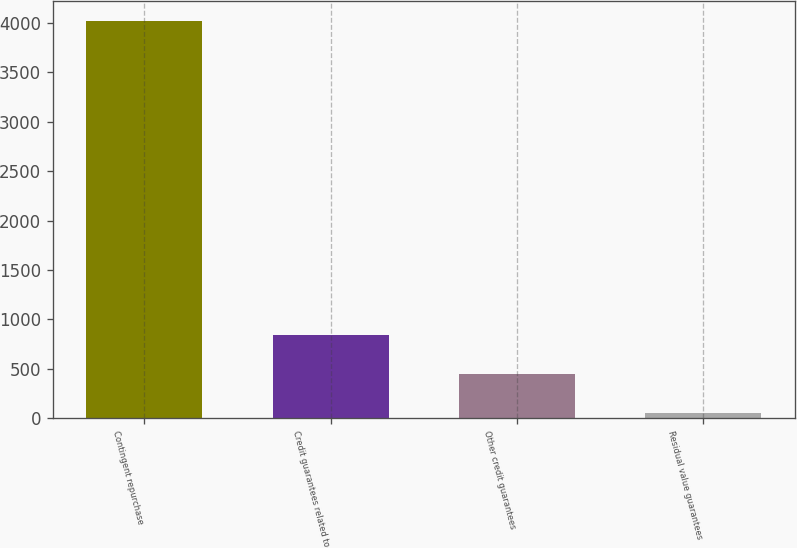<chart> <loc_0><loc_0><loc_500><loc_500><bar_chart><fcel>Contingent repurchase<fcel>Credit guarantees related to<fcel>Other credit guarantees<fcel>Residual value guarantees<nl><fcel>4024<fcel>845.6<fcel>448.3<fcel>51<nl></chart> 